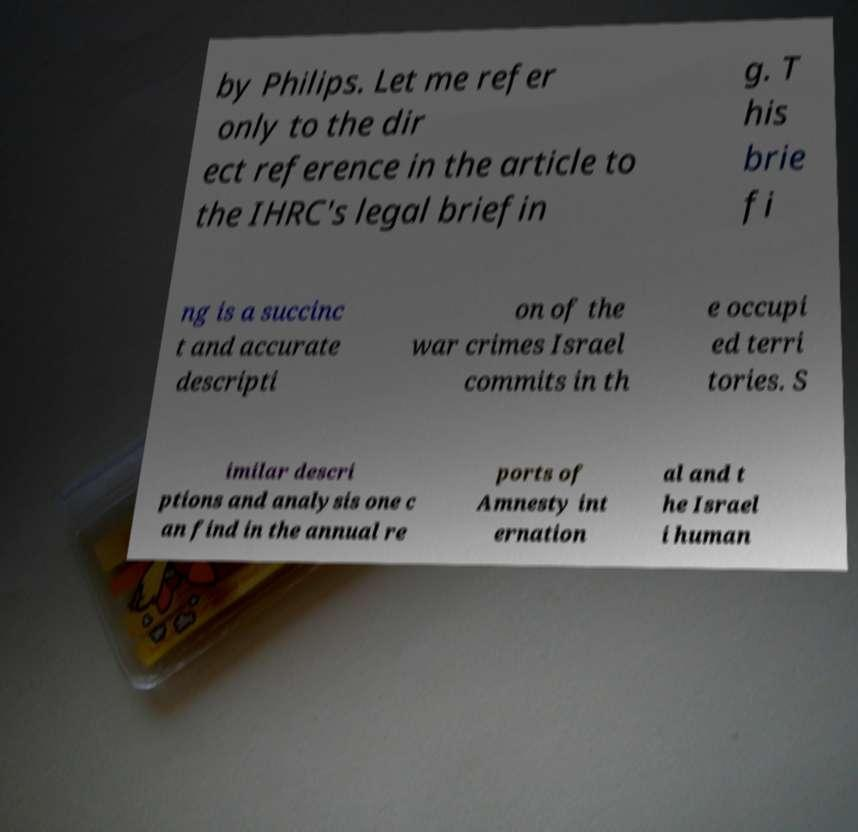Could you extract and type out the text from this image? by Philips. Let me refer only to the dir ect reference in the article to the IHRC's legal briefin g. T his brie fi ng is a succinc t and accurate descripti on of the war crimes Israel commits in th e occupi ed terri tories. S imilar descri ptions and analysis one c an find in the annual re ports of Amnesty int ernation al and t he Israel i human 